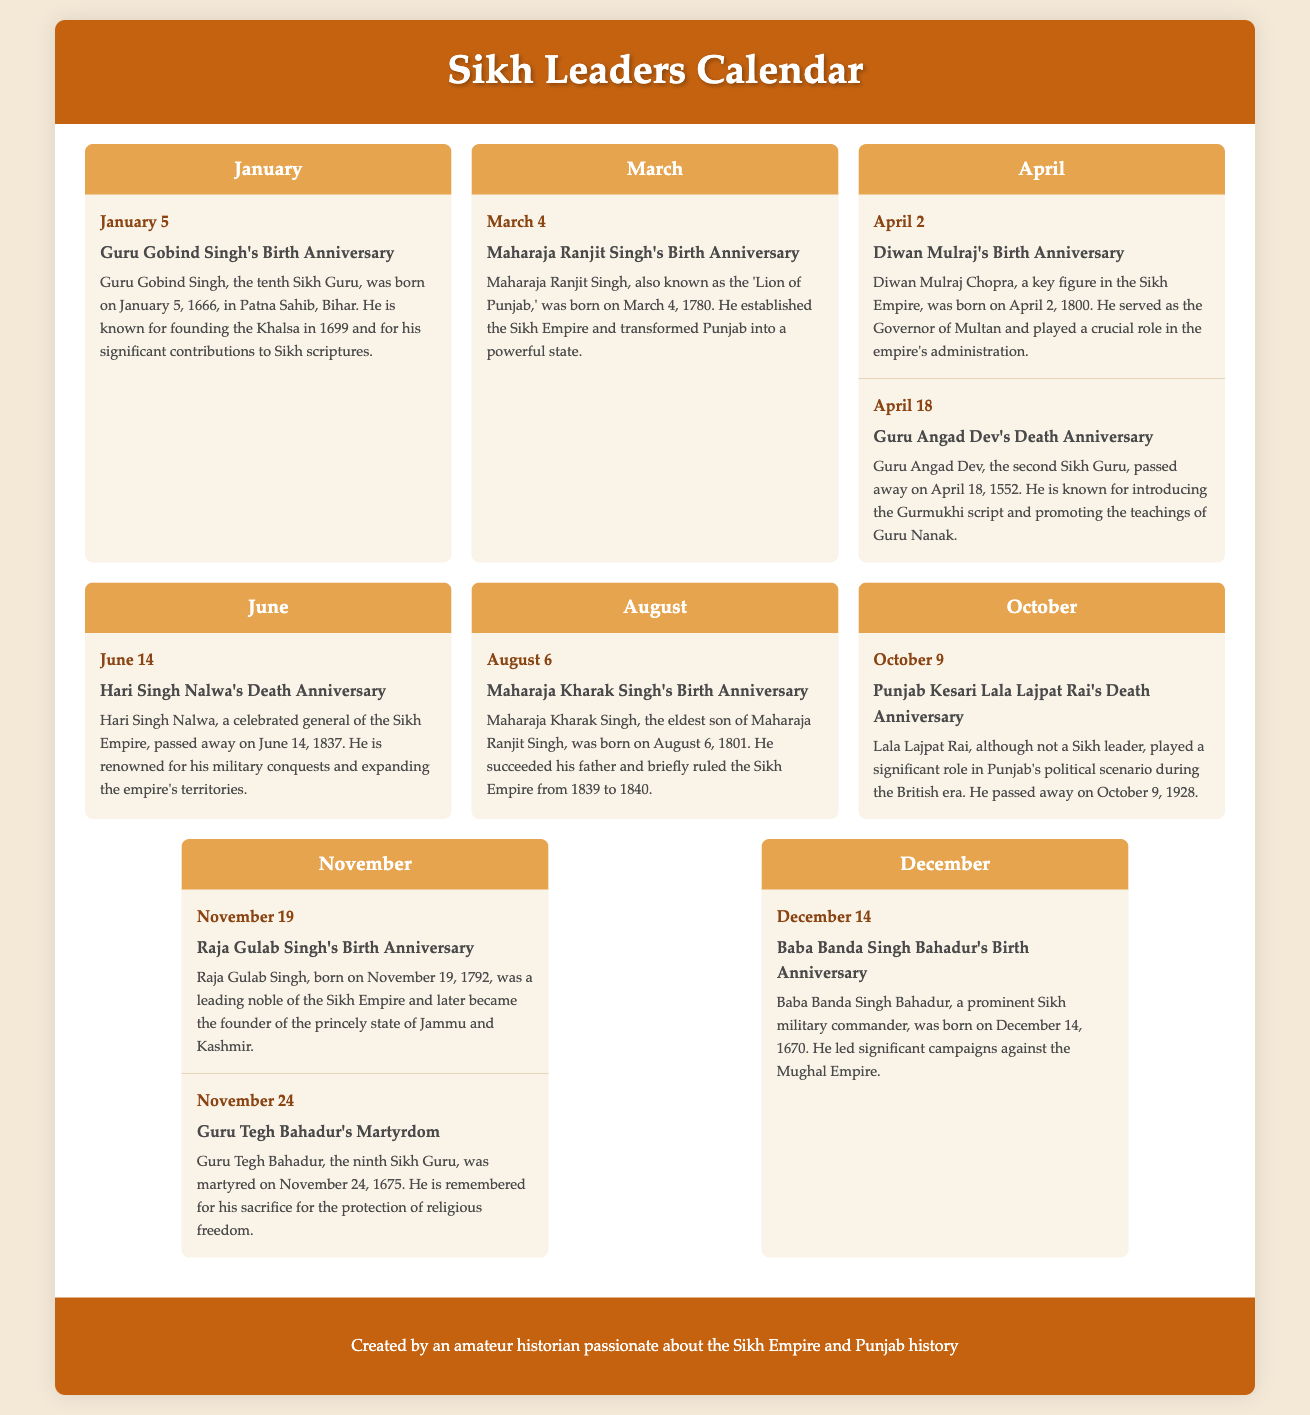What is the birth date of Guru Gobind Singh? Guru Gobind Singh was born on January 5, 1666, which is mentioned in the January section of the document.
Answer: January 5, 1666 Who is celebrated on March 4? The document states that Maharaja Ranjit Singh's birth anniversary is celebrated on March 4, 1780.
Answer: Maharaja Ranjit Singh What is the significance of April 18? April 18 marks the death anniversary of Guru Angad Dev, as stated in the April section of the document.
Answer: Death anniversary of Guru Angad Dev Which Sikh leader is recognized on June 14? The document notes that Hari Singh Nalwa's death anniversary is recognized on June 14, 1837.
Answer: Hari Singh Nalwa What year was Raja Gulab Singh born? Raja Gulab Singh's birth date is mentioned as November 19, 1792, indicating the year of his birth.
Answer: 1792 How many events are listed in the August section? The provided document lists one event in August, which is Maharaja Kharak Singh's birth anniversary.
Answer: One What role did Diwan Mulraj play in the Sikh Empire? According to the document, Diwan Mulraj served as the Governor of Multan and played a crucial role in the empire's administration.
Answer: Governor of Multan Which month contains the martyrdom of Guru Tegh Bahadur? The martyrdom of Guru Tegh Bahadur is mentioned in the November section of the document.
Answer: November Who is remembered for their sacrifice for religious freedom? Guru Tegh Bahadur is noted in the document for his sacrifice for the protection of religious freedom.
Answer: Guru Tegh Bahadur 